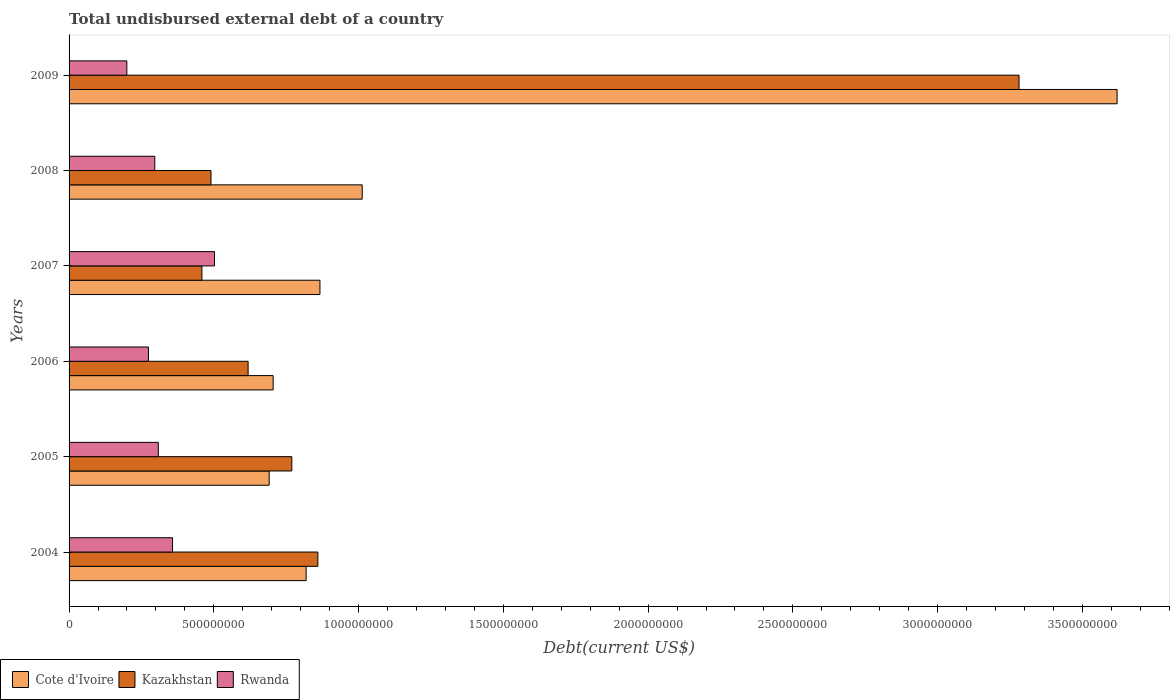How many groups of bars are there?
Your response must be concise. 6. Are the number of bars per tick equal to the number of legend labels?
Offer a very short reply. Yes. How many bars are there on the 4th tick from the top?
Keep it short and to the point. 3. What is the total undisbursed external debt in Rwanda in 2004?
Your response must be concise. 3.57e+08. Across all years, what is the maximum total undisbursed external debt in Rwanda?
Your response must be concise. 5.02e+08. Across all years, what is the minimum total undisbursed external debt in Cote d'Ivoire?
Give a very brief answer. 6.91e+08. In which year was the total undisbursed external debt in Kazakhstan maximum?
Provide a succinct answer. 2009. In which year was the total undisbursed external debt in Rwanda minimum?
Give a very brief answer. 2009. What is the total total undisbursed external debt in Rwanda in the graph?
Your answer should be compact. 1.94e+09. What is the difference between the total undisbursed external debt in Cote d'Ivoire in 2006 and that in 2008?
Provide a succinct answer. -3.08e+08. What is the difference between the total undisbursed external debt in Cote d'Ivoire in 2006 and the total undisbursed external debt in Kazakhstan in 2009?
Your answer should be compact. -2.58e+09. What is the average total undisbursed external debt in Cote d'Ivoire per year?
Offer a very short reply. 1.29e+09. In the year 2005, what is the difference between the total undisbursed external debt in Cote d'Ivoire and total undisbursed external debt in Kazakhstan?
Ensure brevity in your answer.  -7.82e+07. What is the ratio of the total undisbursed external debt in Kazakhstan in 2005 to that in 2009?
Your response must be concise. 0.23. Is the total undisbursed external debt in Rwanda in 2004 less than that in 2008?
Offer a very short reply. No. Is the difference between the total undisbursed external debt in Cote d'Ivoire in 2007 and 2008 greater than the difference between the total undisbursed external debt in Kazakhstan in 2007 and 2008?
Your response must be concise. No. What is the difference between the highest and the second highest total undisbursed external debt in Rwanda?
Provide a short and direct response. 1.45e+08. What is the difference between the highest and the lowest total undisbursed external debt in Kazakhstan?
Your response must be concise. 2.82e+09. In how many years, is the total undisbursed external debt in Cote d'Ivoire greater than the average total undisbursed external debt in Cote d'Ivoire taken over all years?
Offer a terse response. 1. What does the 1st bar from the top in 2005 represents?
Ensure brevity in your answer.  Rwanda. What does the 1st bar from the bottom in 2008 represents?
Keep it short and to the point. Cote d'Ivoire. Is it the case that in every year, the sum of the total undisbursed external debt in Cote d'Ivoire and total undisbursed external debt in Rwanda is greater than the total undisbursed external debt in Kazakhstan?
Ensure brevity in your answer.  Yes. How many bars are there?
Make the answer very short. 18. What is the difference between two consecutive major ticks on the X-axis?
Your answer should be compact. 5.00e+08. Does the graph contain any zero values?
Your answer should be very brief. No. Does the graph contain grids?
Provide a short and direct response. No. What is the title of the graph?
Provide a short and direct response. Total undisbursed external debt of a country. What is the label or title of the X-axis?
Give a very brief answer. Debt(current US$). What is the Debt(current US$) in Cote d'Ivoire in 2004?
Offer a terse response. 8.19e+08. What is the Debt(current US$) in Kazakhstan in 2004?
Your response must be concise. 8.59e+08. What is the Debt(current US$) in Rwanda in 2004?
Your response must be concise. 3.57e+08. What is the Debt(current US$) of Cote d'Ivoire in 2005?
Give a very brief answer. 6.91e+08. What is the Debt(current US$) of Kazakhstan in 2005?
Ensure brevity in your answer.  7.69e+08. What is the Debt(current US$) in Rwanda in 2005?
Provide a short and direct response. 3.08e+08. What is the Debt(current US$) of Cote d'Ivoire in 2006?
Your response must be concise. 7.05e+08. What is the Debt(current US$) of Kazakhstan in 2006?
Make the answer very short. 6.18e+08. What is the Debt(current US$) of Rwanda in 2006?
Keep it short and to the point. 2.74e+08. What is the Debt(current US$) in Cote d'Ivoire in 2007?
Make the answer very short. 8.67e+08. What is the Debt(current US$) in Kazakhstan in 2007?
Make the answer very short. 4.59e+08. What is the Debt(current US$) in Rwanda in 2007?
Your answer should be very brief. 5.02e+08. What is the Debt(current US$) of Cote d'Ivoire in 2008?
Ensure brevity in your answer.  1.01e+09. What is the Debt(current US$) of Kazakhstan in 2008?
Your answer should be compact. 4.90e+08. What is the Debt(current US$) of Rwanda in 2008?
Provide a short and direct response. 2.96e+08. What is the Debt(current US$) in Cote d'Ivoire in 2009?
Provide a short and direct response. 3.62e+09. What is the Debt(current US$) of Kazakhstan in 2009?
Give a very brief answer. 3.28e+09. What is the Debt(current US$) of Rwanda in 2009?
Keep it short and to the point. 2.00e+08. Across all years, what is the maximum Debt(current US$) of Cote d'Ivoire?
Ensure brevity in your answer.  3.62e+09. Across all years, what is the maximum Debt(current US$) of Kazakhstan?
Your answer should be compact. 3.28e+09. Across all years, what is the maximum Debt(current US$) of Rwanda?
Your answer should be compact. 5.02e+08. Across all years, what is the minimum Debt(current US$) in Cote d'Ivoire?
Offer a terse response. 6.91e+08. Across all years, what is the minimum Debt(current US$) of Kazakhstan?
Offer a very short reply. 4.59e+08. Across all years, what is the minimum Debt(current US$) in Rwanda?
Make the answer very short. 2.00e+08. What is the total Debt(current US$) in Cote d'Ivoire in the graph?
Give a very brief answer. 7.71e+09. What is the total Debt(current US$) in Kazakhstan in the graph?
Provide a succinct answer. 6.48e+09. What is the total Debt(current US$) in Rwanda in the graph?
Provide a succinct answer. 1.94e+09. What is the difference between the Debt(current US$) of Cote d'Ivoire in 2004 and that in 2005?
Make the answer very short. 1.28e+08. What is the difference between the Debt(current US$) of Kazakhstan in 2004 and that in 2005?
Your answer should be very brief. 9.00e+07. What is the difference between the Debt(current US$) of Rwanda in 2004 and that in 2005?
Give a very brief answer. 4.91e+07. What is the difference between the Debt(current US$) in Cote d'Ivoire in 2004 and that in 2006?
Your answer should be compact. 1.14e+08. What is the difference between the Debt(current US$) of Kazakhstan in 2004 and that in 2006?
Give a very brief answer. 2.41e+08. What is the difference between the Debt(current US$) of Rwanda in 2004 and that in 2006?
Provide a short and direct response. 8.32e+07. What is the difference between the Debt(current US$) of Cote d'Ivoire in 2004 and that in 2007?
Keep it short and to the point. -4.78e+07. What is the difference between the Debt(current US$) of Kazakhstan in 2004 and that in 2007?
Ensure brevity in your answer.  4.00e+08. What is the difference between the Debt(current US$) in Rwanda in 2004 and that in 2007?
Keep it short and to the point. -1.45e+08. What is the difference between the Debt(current US$) in Cote d'Ivoire in 2004 and that in 2008?
Offer a terse response. -1.94e+08. What is the difference between the Debt(current US$) in Kazakhstan in 2004 and that in 2008?
Give a very brief answer. 3.69e+08. What is the difference between the Debt(current US$) in Rwanda in 2004 and that in 2008?
Make the answer very short. 6.13e+07. What is the difference between the Debt(current US$) of Cote d'Ivoire in 2004 and that in 2009?
Your answer should be compact. -2.80e+09. What is the difference between the Debt(current US$) of Kazakhstan in 2004 and that in 2009?
Your answer should be very brief. -2.42e+09. What is the difference between the Debt(current US$) in Rwanda in 2004 and that in 2009?
Your answer should be compact. 1.58e+08. What is the difference between the Debt(current US$) in Cote d'Ivoire in 2005 and that in 2006?
Keep it short and to the point. -1.38e+07. What is the difference between the Debt(current US$) of Kazakhstan in 2005 and that in 2006?
Offer a terse response. 1.51e+08. What is the difference between the Debt(current US$) in Rwanda in 2005 and that in 2006?
Your answer should be compact. 3.41e+07. What is the difference between the Debt(current US$) of Cote d'Ivoire in 2005 and that in 2007?
Your answer should be very brief. -1.75e+08. What is the difference between the Debt(current US$) in Kazakhstan in 2005 and that in 2007?
Offer a very short reply. 3.11e+08. What is the difference between the Debt(current US$) of Rwanda in 2005 and that in 2007?
Provide a short and direct response. -1.94e+08. What is the difference between the Debt(current US$) of Cote d'Ivoire in 2005 and that in 2008?
Make the answer very short. -3.21e+08. What is the difference between the Debt(current US$) of Kazakhstan in 2005 and that in 2008?
Your answer should be compact. 2.79e+08. What is the difference between the Debt(current US$) of Rwanda in 2005 and that in 2008?
Provide a short and direct response. 1.22e+07. What is the difference between the Debt(current US$) of Cote d'Ivoire in 2005 and that in 2009?
Your response must be concise. -2.93e+09. What is the difference between the Debt(current US$) in Kazakhstan in 2005 and that in 2009?
Ensure brevity in your answer.  -2.51e+09. What is the difference between the Debt(current US$) in Rwanda in 2005 and that in 2009?
Keep it short and to the point. 1.09e+08. What is the difference between the Debt(current US$) in Cote d'Ivoire in 2006 and that in 2007?
Your answer should be compact. -1.62e+08. What is the difference between the Debt(current US$) in Kazakhstan in 2006 and that in 2007?
Provide a succinct answer. 1.60e+08. What is the difference between the Debt(current US$) in Rwanda in 2006 and that in 2007?
Your answer should be very brief. -2.28e+08. What is the difference between the Debt(current US$) of Cote d'Ivoire in 2006 and that in 2008?
Offer a very short reply. -3.08e+08. What is the difference between the Debt(current US$) in Kazakhstan in 2006 and that in 2008?
Keep it short and to the point. 1.28e+08. What is the difference between the Debt(current US$) of Rwanda in 2006 and that in 2008?
Your answer should be compact. -2.18e+07. What is the difference between the Debt(current US$) of Cote d'Ivoire in 2006 and that in 2009?
Your response must be concise. -2.91e+09. What is the difference between the Debt(current US$) in Kazakhstan in 2006 and that in 2009?
Offer a terse response. -2.66e+09. What is the difference between the Debt(current US$) in Rwanda in 2006 and that in 2009?
Give a very brief answer. 7.47e+07. What is the difference between the Debt(current US$) of Cote d'Ivoire in 2007 and that in 2008?
Make the answer very short. -1.46e+08. What is the difference between the Debt(current US$) of Kazakhstan in 2007 and that in 2008?
Ensure brevity in your answer.  -3.13e+07. What is the difference between the Debt(current US$) in Rwanda in 2007 and that in 2008?
Make the answer very short. 2.06e+08. What is the difference between the Debt(current US$) in Cote d'Ivoire in 2007 and that in 2009?
Offer a very short reply. -2.75e+09. What is the difference between the Debt(current US$) in Kazakhstan in 2007 and that in 2009?
Offer a terse response. -2.82e+09. What is the difference between the Debt(current US$) of Rwanda in 2007 and that in 2009?
Offer a very short reply. 3.03e+08. What is the difference between the Debt(current US$) of Cote d'Ivoire in 2008 and that in 2009?
Offer a terse response. -2.61e+09. What is the difference between the Debt(current US$) in Kazakhstan in 2008 and that in 2009?
Keep it short and to the point. -2.79e+09. What is the difference between the Debt(current US$) in Rwanda in 2008 and that in 2009?
Offer a very short reply. 9.65e+07. What is the difference between the Debt(current US$) of Cote d'Ivoire in 2004 and the Debt(current US$) of Kazakhstan in 2005?
Keep it short and to the point. 4.94e+07. What is the difference between the Debt(current US$) of Cote d'Ivoire in 2004 and the Debt(current US$) of Rwanda in 2005?
Provide a short and direct response. 5.11e+08. What is the difference between the Debt(current US$) of Kazakhstan in 2004 and the Debt(current US$) of Rwanda in 2005?
Ensure brevity in your answer.  5.51e+08. What is the difference between the Debt(current US$) in Cote d'Ivoire in 2004 and the Debt(current US$) in Kazakhstan in 2006?
Provide a short and direct response. 2.00e+08. What is the difference between the Debt(current US$) in Cote d'Ivoire in 2004 and the Debt(current US$) in Rwanda in 2006?
Give a very brief answer. 5.45e+08. What is the difference between the Debt(current US$) of Kazakhstan in 2004 and the Debt(current US$) of Rwanda in 2006?
Make the answer very short. 5.85e+08. What is the difference between the Debt(current US$) in Cote d'Ivoire in 2004 and the Debt(current US$) in Kazakhstan in 2007?
Make the answer very short. 3.60e+08. What is the difference between the Debt(current US$) in Cote d'Ivoire in 2004 and the Debt(current US$) in Rwanda in 2007?
Your answer should be very brief. 3.16e+08. What is the difference between the Debt(current US$) of Kazakhstan in 2004 and the Debt(current US$) of Rwanda in 2007?
Offer a very short reply. 3.57e+08. What is the difference between the Debt(current US$) in Cote d'Ivoire in 2004 and the Debt(current US$) in Kazakhstan in 2008?
Provide a short and direct response. 3.29e+08. What is the difference between the Debt(current US$) of Cote d'Ivoire in 2004 and the Debt(current US$) of Rwanda in 2008?
Give a very brief answer. 5.23e+08. What is the difference between the Debt(current US$) in Kazakhstan in 2004 and the Debt(current US$) in Rwanda in 2008?
Offer a terse response. 5.63e+08. What is the difference between the Debt(current US$) in Cote d'Ivoire in 2004 and the Debt(current US$) in Kazakhstan in 2009?
Give a very brief answer. -2.46e+09. What is the difference between the Debt(current US$) in Cote d'Ivoire in 2004 and the Debt(current US$) in Rwanda in 2009?
Make the answer very short. 6.19e+08. What is the difference between the Debt(current US$) in Kazakhstan in 2004 and the Debt(current US$) in Rwanda in 2009?
Your answer should be very brief. 6.60e+08. What is the difference between the Debt(current US$) in Cote d'Ivoire in 2005 and the Debt(current US$) in Kazakhstan in 2006?
Make the answer very short. 7.28e+07. What is the difference between the Debt(current US$) of Cote d'Ivoire in 2005 and the Debt(current US$) of Rwanda in 2006?
Keep it short and to the point. 4.17e+08. What is the difference between the Debt(current US$) of Kazakhstan in 2005 and the Debt(current US$) of Rwanda in 2006?
Make the answer very short. 4.95e+08. What is the difference between the Debt(current US$) of Cote d'Ivoire in 2005 and the Debt(current US$) of Kazakhstan in 2007?
Your response must be concise. 2.32e+08. What is the difference between the Debt(current US$) of Cote d'Ivoire in 2005 and the Debt(current US$) of Rwanda in 2007?
Offer a very short reply. 1.89e+08. What is the difference between the Debt(current US$) of Kazakhstan in 2005 and the Debt(current US$) of Rwanda in 2007?
Ensure brevity in your answer.  2.67e+08. What is the difference between the Debt(current US$) of Cote d'Ivoire in 2005 and the Debt(current US$) of Kazakhstan in 2008?
Your response must be concise. 2.01e+08. What is the difference between the Debt(current US$) in Cote d'Ivoire in 2005 and the Debt(current US$) in Rwanda in 2008?
Provide a succinct answer. 3.95e+08. What is the difference between the Debt(current US$) of Kazakhstan in 2005 and the Debt(current US$) of Rwanda in 2008?
Give a very brief answer. 4.73e+08. What is the difference between the Debt(current US$) in Cote d'Ivoire in 2005 and the Debt(current US$) in Kazakhstan in 2009?
Keep it short and to the point. -2.59e+09. What is the difference between the Debt(current US$) of Cote d'Ivoire in 2005 and the Debt(current US$) of Rwanda in 2009?
Your answer should be compact. 4.92e+08. What is the difference between the Debt(current US$) of Kazakhstan in 2005 and the Debt(current US$) of Rwanda in 2009?
Your answer should be compact. 5.70e+08. What is the difference between the Debt(current US$) of Cote d'Ivoire in 2006 and the Debt(current US$) of Kazakhstan in 2007?
Your answer should be compact. 2.46e+08. What is the difference between the Debt(current US$) in Cote d'Ivoire in 2006 and the Debt(current US$) in Rwanda in 2007?
Provide a succinct answer. 2.03e+08. What is the difference between the Debt(current US$) in Kazakhstan in 2006 and the Debt(current US$) in Rwanda in 2007?
Give a very brief answer. 1.16e+08. What is the difference between the Debt(current US$) in Cote d'Ivoire in 2006 and the Debt(current US$) in Kazakhstan in 2008?
Your answer should be compact. 2.15e+08. What is the difference between the Debt(current US$) in Cote d'Ivoire in 2006 and the Debt(current US$) in Rwanda in 2008?
Offer a very short reply. 4.09e+08. What is the difference between the Debt(current US$) in Kazakhstan in 2006 and the Debt(current US$) in Rwanda in 2008?
Offer a terse response. 3.22e+08. What is the difference between the Debt(current US$) in Cote d'Ivoire in 2006 and the Debt(current US$) in Kazakhstan in 2009?
Offer a very short reply. -2.58e+09. What is the difference between the Debt(current US$) in Cote d'Ivoire in 2006 and the Debt(current US$) in Rwanda in 2009?
Provide a short and direct response. 5.05e+08. What is the difference between the Debt(current US$) in Kazakhstan in 2006 and the Debt(current US$) in Rwanda in 2009?
Keep it short and to the point. 4.19e+08. What is the difference between the Debt(current US$) of Cote d'Ivoire in 2007 and the Debt(current US$) of Kazakhstan in 2008?
Ensure brevity in your answer.  3.76e+08. What is the difference between the Debt(current US$) in Cote d'Ivoire in 2007 and the Debt(current US$) in Rwanda in 2008?
Offer a terse response. 5.71e+08. What is the difference between the Debt(current US$) in Kazakhstan in 2007 and the Debt(current US$) in Rwanda in 2008?
Offer a terse response. 1.63e+08. What is the difference between the Debt(current US$) in Cote d'Ivoire in 2007 and the Debt(current US$) in Kazakhstan in 2009?
Make the answer very short. -2.41e+09. What is the difference between the Debt(current US$) in Cote d'Ivoire in 2007 and the Debt(current US$) in Rwanda in 2009?
Provide a succinct answer. 6.67e+08. What is the difference between the Debt(current US$) in Kazakhstan in 2007 and the Debt(current US$) in Rwanda in 2009?
Your response must be concise. 2.59e+08. What is the difference between the Debt(current US$) of Cote d'Ivoire in 2008 and the Debt(current US$) of Kazakhstan in 2009?
Provide a succinct answer. -2.27e+09. What is the difference between the Debt(current US$) of Cote d'Ivoire in 2008 and the Debt(current US$) of Rwanda in 2009?
Keep it short and to the point. 8.13e+08. What is the difference between the Debt(current US$) in Kazakhstan in 2008 and the Debt(current US$) in Rwanda in 2009?
Make the answer very short. 2.91e+08. What is the average Debt(current US$) in Cote d'Ivoire per year?
Your answer should be very brief. 1.29e+09. What is the average Debt(current US$) of Kazakhstan per year?
Your response must be concise. 1.08e+09. What is the average Debt(current US$) of Rwanda per year?
Your answer should be compact. 3.23e+08. In the year 2004, what is the difference between the Debt(current US$) of Cote d'Ivoire and Debt(current US$) of Kazakhstan?
Give a very brief answer. -4.06e+07. In the year 2004, what is the difference between the Debt(current US$) in Cote d'Ivoire and Debt(current US$) in Rwanda?
Your response must be concise. 4.61e+08. In the year 2004, what is the difference between the Debt(current US$) in Kazakhstan and Debt(current US$) in Rwanda?
Provide a short and direct response. 5.02e+08. In the year 2005, what is the difference between the Debt(current US$) of Cote d'Ivoire and Debt(current US$) of Kazakhstan?
Ensure brevity in your answer.  -7.82e+07. In the year 2005, what is the difference between the Debt(current US$) of Cote d'Ivoire and Debt(current US$) of Rwanda?
Keep it short and to the point. 3.83e+08. In the year 2005, what is the difference between the Debt(current US$) of Kazakhstan and Debt(current US$) of Rwanda?
Offer a terse response. 4.61e+08. In the year 2006, what is the difference between the Debt(current US$) in Cote d'Ivoire and Debt(current US$) in Kazakhstan?
Make the answer very short. 8.65e+07. In the year 2006, what is the difference between the Debt(current US$) in Cote d'Ivoire and Debt(current US$) in Rwanda?
Offer a terse response. 4.31e+08. In the year 2006, what is the difference between the Debt(current US$) of Kazakhstan and Debt(current US$) of Rwanda?
Your response must be concise. 3.44e+08. In the year 2007, what is the difference between the Debt(current US$) of Cote d'Ivoire and Debt(current US$) of Kazakhstan?
Your answer should be compact. 4.08e+08. In the year 2007, what is the difference between the Debt(current US$) in Cote d'Ivoire and Debt(current US$) in Rwanda?
Your answer should be compact. 3.64e+08. In the year 2007, what is the difference between the Debt(current US$) in Kazakhstan and Debt(current US$) in Rwanda?
Offer a very short reply. -4.34e+07. In the year 2008, what is the difference between the Debt(current US$) in Cote d'Ivoire and Debt(current US$) in Kazakhstan?
Offer a terse response. 5.22e+08. In the year 2008, what is the difference between the Debt(current US$) of Cote d'Ivoire and Debt(current US$) of Rwanda?
Make the answer very short. 7.16e+08. In the year 2008, what is the difference between the Debt(current US$) of Kazakhstan and Debt(current US$) of Rwanda?
Offer a very short reply. 1.94e+08. In the year 2009, what is the difference between the Debt(current US$) in Cote d'Ivoire and Debt(current US$) in Kazakhstan?
Your answer should be compact. 3.39e+08. In the year 2009, what is the difference between the Debt(current US$) of Cote d'Ivoire and Debt(current US$) of Rwanda?
Your answer should be very brief. 3.42e+09. In the year 2009, what is the difference between the Debt(current US$) in Kazakhstan and Debt(current US$) in Rwanda?
Keep it short and to the point. 3.08e+09. What is the ratio of the Debt(current US$) in Cote d'Ivoire in 2004 to that in 2005?
Keep it short and to the point. 1.18. What is the ratio of the Debt(current US$) of Kazakhstan in 2004 to that in 2005?
Your response must be concise. 1.12. What is the ratio of the Debt(current US$) of Rwanda in 2004 to that in 2005?
Your answer should be compact. 1.16. What is the ratio of the Debt(current US$) of Cote d'Ivoire in 2004 to that in 2006?
Your answer should be compact. 1.16. What is the ratio of the Debt(current US$) of Kazakhstan in 2004 to that in 2006?
Provide a short and direct response. 1.39. What is the ratio of the Debt(current US$) in Rwanda in 2004 to that in 2006?
Offer a very short reply. 1.3. What is the ratio of the Debt(current US$) of Cote d'Ivoire in 2004 to that in 2007?
Make the answer very short. 0.94. What is the ratio of the Debt(current US$) of Kazakhstan in 2004 to that in 2007?
Offer a very short reply. 1.87. What is the ratio of the Debt(current US$) of Rwanda in 2004 to that in 2007?
Give a very brief answer. 0.71. What is the ratio of the Debt(current US$) in Cote d'Ivoire in 2004 to that in 2008?
Offer a very short reply. 0.81. What is the ratio of the Debt(current US$) of Kazakhstan in 2004 to that in 2008?
Offer a terse response. 1.75. What is the ratio of the Debt(current US$) of Rwanda in 2004 to that in 2008?
Give a very brief answer. 1.21. What is the ratio of the Debt(current US$) of Cote d'Ivoire in 2004 to that in 2009?
Offer a very short reply. 0.23. What is the ratio of the Debt(current US$) of Kazakhstan in 2004 to that in 2009?
Your response must be concise. 0.26. What is the ratio of the Debt(current US$) of Rwanda in 2004 to that in 2009?
Your response must be concise. 1.79. What is the ratio of the Debt(current US$) in Cote d'Ivoire in 2005 to that in 2006?
Your answer should be very brief. 0.98. What is the ratio of the Debt(current US$) of Kazakhstan in 2005 to that in 2006?
Your answer should be compact. 1.24. What is the ratio of the Debt(current US$) of Rwanda in 2005 to that in 2006?
Offer a terse response. 1.12. What is the ratio of the Debt(current US$) of Cote d'Ivoire in 2005 to that in 2007?
Your answer should be very brief. 0.8. What is the ratio of the Debt(current US$) in Kazakhstan in 2005 to that in 2007?
Offer a very short reply. 1.68. What is the ratio of the Debt(current US$) in Rwanda in 2005 to that in 2007?
Give a very brief answer. 0.61. What is the ratio of the Debt(current US$) in Cote d'Ivoire in 2005 to that in 2008?
Give a very brief answer. 0.68. What is the ratio of the Debt(current US$) of Kazakhstan in 2005 to that in 2008?
Provide a short and direct response. 1.57. What is the ratio of the Debt(current US$) of Rwanda in 2005 to that in 2008?
Ensure brevity in your answer.  1.04. What is the ratio of the Debt(current US$) of Cote d'Ivoire in 2005 to that in 2009?
Offer a very short reply. 0.19. What is the ratio of the Debt(current US$) of Kazakhstan in 2005 to that in 2009?
Make the answer very short. 0.23. What is the ratio of the Debt(current US$) in Rwanda in 2005 to that in 2009?
Your answer should be compact. 1.54. What is the ratio of the Debt(current US$) of Cote d'Ivoire in 2006 to that in 2007?
Keep it short and to the point. 0.81. What is the ratio of the Debt(current US$) in Kazakhstan in 2006 to that in 2007?
Provide a short and direct response. 1.35. What is the ratio of the Debt(current US$) in Rwanda in 2006 to that in 2007?
Ensure brevity in your answer.  0.55. What is the ratio of the Debt(current US$) in Cote d'Ivoire in 2006 to that in 2008?
Keep it short and to the point. 0.7. What is the ratio of the Debt(current US$) in Kazakhstan in 2006 to that in 2008?
Your answer should be compact. 1.26. What is the ratio of the Debt(current US$) of Rwanda in 2006 to that in 2008?
Your answer should be very brief. 0.93. What is the ratio of the Debt(current US$) of Cote d'Ivoire in 2006 to that in 2009?
Ensure brevity in your answer.  0.19. What is the ratio of the Debt(current US$) in Kazakhstan in 2006 to that in 2009?
Make the answer very short. 0.19. What is the ratio of the Debt(current US$) in Rwanda in 2006 to that in 2009?
Offer a very short reply. 1.37. What is the ratio of the Debt(current US$) of Cote d'Ivoire in 2007 to that in 2008?
Make the answer very short. 0.86. What is the ratio of the Debt(current US$) of Kazakhstan in 2007 to that in 2008?
Keep it short and to the point. 0.94. What is the ratio of the Debt(current US$) of Rwanda in 2007 to that in 2008?
Your answer should be very brief. 1.7. What is the ratio of the Debt(current US$) of Cote d'Ivoire in 2007 to that in 2009?
Your answer should be very brief. 0.24. What is the ratio of the Debt(current US$) in Kazakhstan in 2007 to that in 2009?
Ensure brevity in your answer.  0.14. What is the ratio of the Debt(current US$) of Rwanda in 2007 to that in 2009?
Your response must be concise. 2.52. What is the ratio of the Debt(current US$) of Cote d'Ivoire in 2008 to that in 2009?
Your answer should be very brief. 0.28. What is the ratio of the Debt(current US$) of Kazakhstan in 2008 to that in 2009?
Provide a short and direct response. 0.15. What is the ratio of the Debt(current US$) in Rwanda in 2008 to that in 2009?
Your response must be concise. 1.48. What is the difference between the highest and the second highest Debt(current US$) in Cote d'Ivoire?
Offer a very short reply. 2.61e+09. What is the difference between the highest and the second highest Debt(current US$) of Kazakhstan?
Your response must be concise. 2.42e+09. What is the difference between the highest and the second highest Debt(current US$) in Rwanda?
Keep it short and to the point. 1.45e+08. What is the difference between the highest and the lowest Debt(current US$) of Cote d'Ivoire?
Your answer should be very brief. 2.93e+09. What is the difference between the highest and the lowest Debt(current US$) in Kazakhstan?
Keep it short and to the point. 2.82e+09. What is the difference between the highest and the lowest Debt(current US$) in Rwanda?
Make the answer very short. 3.03e+08. 